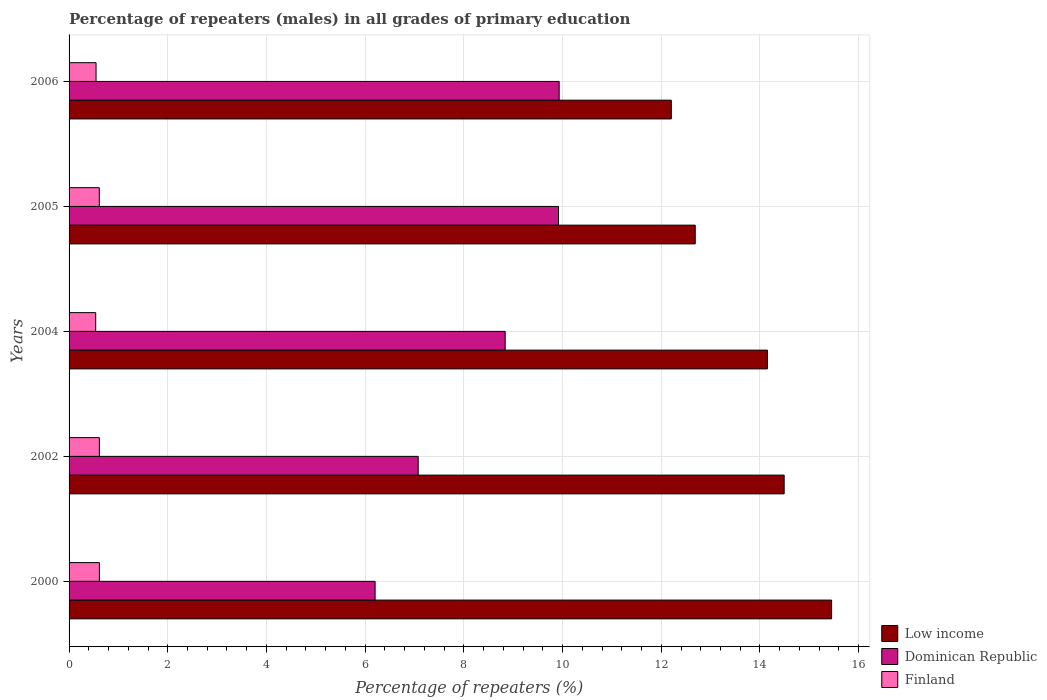How many groups of bars are there?
Offer a terse response. 5. Are the number of bars per tick equal to the number of legend labels?
Your answer should be very brief. Yes. Are the number of bars on each tick of the Y-axis equal?
Make the answer very short. Yes. How many bars are there on the 3rd tick from the bottom?
Offer a very short reply. 3. What is the percentage of repeaters (males) in Dominican Republic in 2006?
Make the answer very short. 9.93. Across all years, what is the maximum percentage of repeaters (males) in Finland?
Make the answer very short. 0.61. Across all years, what is the minimum percentage of repeaters (males) in Dominican Republic?
Offer a very short reply. 6.2. In which year was the percentage of repeaters (males) in Finland maximum?
Ensure brevity in your answer.  2000. What is the total percentage of repeaters (males) in Finland in the graph?
Offer a terse response. 2.93. What is the difference between the percentage of repeaters (males) in Dominican Republic in 2004 and that in 2006?
Offer a terse response. -1.09. What is the difference between the percentage of repeaters (males) in Low income in 2004 and the percentage of repeaters (males) in Dominican Republic in 2002?
Give a very brief answer. 7.08. What is the average percentage of repeaters (males) in Dominican Republic per year?
Give a very brief answer. 8.39. In the year 2000, what is the difference between the percentage of repeaters (males) in Low income and percentage of repeaters (males) in Finland?
Offer a terse response. 14.84. What is the ratio of the percentage of repeaters (males) in Dominican Republic in 2002 to that in 2006?
Offer a terse response. 0.71. Is the percentage of repeaters (males) in Dominican Republic in 2002 less than that in 2006?
Provide a succinct answer. Yes. What is the difference between the highest and the second highest percentage of repeaters (males) in Finland?
Provide a succinct answer. 0. What is the difference between the highest and the lowest percentage of repeaters (males) in Dominican Republic?
Offer a terse response. 3.73. In how many years, is the percentage of repeaters (males) in Low income greater than the average percentage of repeaters (males) in Low income taken over all years?
Your answer should be compact. 3. What does the 2nd bar from the top in 2000 represents?
Provide a short and direct response. Dominican Republic. What does the 1st bar from the bottom in 2005 represents?
Offer a terse response. Low income. Is it the case that in every year, the sum of the percentage of repeaters (males) in Low income and percentage of repeaters (males) in Finland is greater than the percentage of repeaters (males) in Dominican Republic?
Keep it short and to the point. Yes. Are all the bars in the graph horizontal?
Make the answer very short. Yes. What is the difference between two consecutive major ticks on the X-axis?
Provide a short and direct response. 2. Does the graph contain any zero values?
Your answer should be compact. No. What is the title of the graph?
Keep it short and to the point. Percentage of repeaters (males) in all grades of primary education. Does "France" appear as one of the legend labels in the graph?
Give a very brief answer. No. What is the label or title of the X-axis?
Ensure brevity in your answer.  Percentage of repeaters (%). What is the Percentage of repeaters (%) of Low income in 2000?
Provide a short and direct response. 15.45. What is the Percentage of repeaters (%) of Dominican Republic in 2000?
Give a very brief answer. 6.2. What is the Percentage of repeaters (%) of Finland in 2000?
Give a very brief answer. 0.61. What is the Percentage of repeaters (%) in Low income in 2002?
Provide a short and direct response. 14.49. What is the Percentage of repeaters (%) of Dominican Republic in 2002?
Your response must be concise. 7.07. What is the Percentage of repeaters (%) of Finland in 2002?
Give a very brief answer. 0.61. What is the Percentage of repeaters (%) of Low income in 2004?
Make the answer very short. 14.15. What is the Percentage of repeaters (%) in Dominican Republic in 2004?
Offer a terse response. 8.84. What is the Percentage of repeaters (%) of Finland in 2004?
Provide a succinct answer. 0.54. What is the Percentage of repeaters (%) of Low income in 2005?
Give a very brief answer. 12.69. What is the Percentage of repeaters (%) of Dominican Republic in 2005?
Provide a succinct answer. 9.92. What is the Percentage of repeaters (%) of Finland in 2005?
Provide a short and direct response. 0.61. What is the Percentage of repeaters (%) in Low income in 2006?
Your answer should be very brief. 12.2. What is the Percentage of repeaters (%) of Dominican Republic in 2006?
Make the answer very short. 9.93. What is the Percentage of repeaters (%) in Finland in 2006?
Your answer should be very brief. 0.55. Across all years, what is the maximum Percentage of repeaters (%) in Low income?
Your answer should be very brief. 15.45. Across all years, what is the maximum Percentage of repeaters (%) in Dominican Republic?
Give a very brief answer. 9.93. Across all years, what is the maximum Percentage of repeaters (%) of Finland?
Make the answer very short. 0.61. Across all years, what is the minimum Percentage of repeaters (%) in Low income?
Your response must be concise. 12.2. Across all years, what is the minimum Percentage of repeaters (%) in Dominican Republic?
Give a very brief answer. 6.2. Across all years, what is the minimum Percentage of repeaters (%) in Finland?
Offer a terse response. 0.54. What is the total Percentage of repeaters (%) of Low income in the graph?
Ensure brevity in your answer.  68.99. What is the total Percentage of repeaters (%) of Dominican Republic in the graph?
Ensure brevity in your answer.  41.96. What is the total Percentage of repeaters (%) of Finland in the graph?
Make the answer very short. 2.93. What is the difference between the Percentage of repeaters (%) in Low income in 2000 and that in 2002?
Give a very brief answer. 0.96. What is the difference between the Percentage of repeaters (%) in Dominican Republic in 2000 and that in 2002?
Give a very brief answer. -0.87. What is the difference between the Percentage of repeaters (%) in Finland in 2000 and that in 2002?
Give a very brief answer. 0. What is the difference between the Percentage of repeaters (%) of Low income in 2000 and that in 2004?
Provide a short and direct response. 1.3. What is the difference between the Percentage of repeaters (%) in Dominican Republic in 2000 and that in 2004?
Offer a very short reply. -2.64. What is the difference between the Percentage of repeaters (%) in Finland in 2000 and that in 2004?
Your answer should be very brief. 0.07. What is the difference between the Percentage of repeaters (%) in Low income in 2000 and that in 2005?
Your answer should be compact. 2.76. What is the difference between the Percentage of repeaters (%) in Dominican Republic in 2000 and that in 2005?
Offer a very short reply. -3.72. What is the difference between the Percentage of repeaters (%) in Finland in 2000 and that in 2005?
Offer a terse response. 0. What is the difference between the Percentage of repeaters (%) of Low income in 2000 and that in 2006?
Provide a succinct answer. 3.25. What is the difference between the Percentage of repeaters (%) in Dominican Republic in 2000 and that in 2006?
Keep it short and to the point. -3.73. What is the difference between the Percentage of repeaters (%) of Finland in 2000 and that in 2006?
Keep it short and to the point. 0.07. What is the difference between the Percentage of repeaters (%) in Low income in 2002 and that in 2004?
Give a very brief answer. 0.34. What is the difference between the Percentage of repeaters (%) in Dominican Republic in 2002 and that in 2004?
Offer a very short reply. -1.76. What is the difference between the Percentage of repeaters (%) of Finland in 2002 and that in 2004?
Offer a terse response. 0.07. What is the difference between the Percentage of repeaters (%) in Low income in 2002 and that in 2005?
Your answer should be compact. 1.8. What is the difference between the Percentage of repeaters (%) in Dominican Republic in 2002 and that in 2005?
Keep it short and to the point. -2.84. What is the difference between the Percentage of repeaters (%) in Finland in 2002 and that in 2005?
Offer a terse response. 0. What is the difference between the Percentage of repeaters (%) in Low income in 2002 and that in 2006?
Ensure brevity in your answer.  2.29. What is the difference between the Percentage of repeaters (%) in Dominican Republic in 2002 and that in 2006?
Ensure brevity in your answer.  -2.86. What is the difference between the Percentage of repeaters (%) in Finland in 2002 and that in 2006?
Provide a succinct answer. 0.07. What is the difference between the Percentage of repeaters (%) of Low income in 2004 and that in 2005?
Offer a terse response. 1.46. What is the difference between the Percentage of repeaters (%) of Dominican Republic in 2004 and that in 2005?
Your answer should be compact. -1.08. What is the difference between the Percentage of repeaters (%) in Finland in 2004 and that in 2005?
Offer a terse response. -0.07. What is the difference between the Percentage of repeaters (%) in Low income in 2004 and that in 2006?
Ensure brevity in your answer.  1.95. What is the difference between the Percentage of repeaters (%) in Dominican Republic in 2004 and that in 2006?
Offer a terse response. -1.09. What is the difference between the Percentage of repeaters (%) of Finland in 2004 and that in 2006?
Your answer should be very brief. -0.01. What is the difference between the Percentage of repeaters (%) of Low income in 2005 and that in 2006?
Offer a very short reply. 0.48. What is the difference between the Percentage of repeaters (%) in Dominican Republic in 2005 and that in 2006?
Your response must be concise. -0.01. What is the difference between the Percentage of repeaters (%) of Finland in 2005 and that in 2006?
Make the answer very short. 0.07. What is the difference between the Percentage of repeaters (%) in Low income in 2000 and the Percentage of repeaters (%) in Dominican Republic in 2002?
Give a very brief answer. 8.38. What is the difference between the Percentage of repeaters (%) in Low income in 2000 and the Percentage of repeaters (%) in Finland in 2002?
Give a very brief answer. 14.84. What is the difference between the Percentage of repeaters (%) of Dominican Republic in 2000 and the Percentage of repeaters (%) of Finland in 2002?
Ensure brevity in your answer.  5.59. What is the difference between the Percentage of repeaters (%) of Low income in 2000 and the Percentage of repeaters (%) of Dominican Republic in 2004?
Provide a short and direct response. 6.61. What is the difference between the Percentage of repeaters (%) in Low income in 2000 and the Percentage of repeaters (%) in Finland in 2004?
Provide a short and direct response. 14.91. What is the difference between the Percentage of repeaters (%) in Dominican Republic in 2000 and the Percentage of repeaters (%) in Finland in 2004?
Give a very brief answer. 5.66. What is the difference between the Percentage of repeaters (%) of Low income in 2000 and the Percentage of repeaters (%) of Dominican Republic in 2005?
Give a very brief answer. 5.53. What is the difference between the Percentage of repeaters (%) in Low income in 2000 and the Percentage of repeaters (%) in Finland in 2005?
Provide a short and direct response. 14.84. What is the difference between the Percentage of repeaters (%) of Dominican Republic in 2000 and the Percentage of repeaters (%) of Finland in 2005?
Provide a succinct answer. 5.59. What is the difference between the Percentage of repeaters (%) in Low income in 2000 and the Percentage of repeaters (%) in Dominican Republic in 2006?
Offer a terse response. 5.52. What is the difference between the Percentage of repeaters (%) in Low income in 2000 and the Percentage of repeaters (%) in Finland in 2006?
Offer a very short reply. 14.91. What is the difference between the Percentage of repeaters (%) in Dominican Republic in 2000 and the Percentage of repeaters (%) in Finland in 2006?
Offer a terse response. 5.65. What is the difference between the Percentage of repeaters (%) in Low income in 2002 and the Percentage of repeaters (%) in Dominican Republic in 2004?
Give a very brief answer. 5.65. What is the difference between the Percentage of repeaters (%) of Low income in 2002 and the Percentage of repeaters (%) of Finland in 2004?
Ensure brevity in your answer.  13.95. What is the difference between the Percentage of repeaters (%) of Dominican Republic in 2002 and the Percentage of repeaters (%) of Finland in 2004?
Make the answer very short. 6.53. What is the difference between the Percentage of repeaters (%) in Low income in 2002 and the Percentage of repeaters (%) in Dominican Republic in 2005?
Keep it short and to the point. 4.57. What is the difference between the Percentage of repeaters (%) of Low income in 2002 and the Percentage of repeaters (%) of Finland in 2005?
Your response must be concise. 13.88. What is the difference between the Percentage of repeaters (%) in Dominican Republic in 2002 and the Percentage of repeaters (%) in Finland in 2005?
Make the answer very short. 6.46. What is the difference between the Percentage of repeaters (%) of Low income in 2002 and the Percentage of repeaters (%) of Dominican Republic in 2006?
Provide a short and direct response. 4.56. What is the difference between the Percentage of repeaters (%) of Low income in 2002 and the Percentage of repeaters (%) of Finland in 2006?
Your response must be concise. 13.94. What is the difference between the Percentage of repeaters (%) in Dominican Republic in 2002 and the Percentage of repeaters (%) in Finland in 2006?
Your answer should be very brief. 6.53. What is the difference between the Percentage of repeaters (%) of Low income in 2004 and the Percentage of repeaters (%) of Dominican Republic in 2005?
Your response must be concise. 4.23. What is the difference between the Percentage of repeaters (%) of Low income in 2004 and the Percentage of repeaters (%) of Finland in 2005?
Offer a very short reply. 13.54. What is the difference between the Percentage of repeaters (%) of Dominican Republic in 2004 and the Percentage of repeaters (%) of Finland in 2005?
Provide a short and direct response. 8.22. What is the difference between the Percentage of repeaters (%) of Low income in 2004 and the Percentage of repeaters (%) of Dominican Republic in 2006?
Ensure brevity in your answer.  4.22. What is the difference between the Percentage of repeaters (%) of Low income in 2004 and the Percentage of repeaters (%) of Finland in 2006?
Keep it short and to the point. 13.6. What is the difference between the Percentage of repeaters (%) of Dominican Republic in 2004 and the Percentage of repeaters (%) of Finland in 2006?
Offer a terse response. 8.29. What is the difference between the Percentage of repeaters (%) in Low income in 2005 and the Percentage of repeaters (%) in Dominican Republic in 2006?
Your answer should be very brief. 2.76. What is the difference between the Percentage of repeaters (%) of Low income in 2005 and the Percentage of repeaters (%) of Finland in 2006?
Provide a succinct answer. 12.14. What is the difference between the Percentage of repeaters (%) in Dominican Republic in 2005 and the Percentage of repeaters (%) in Finland in 2006?
Offer a very short reply. 9.37. What is the average Percentage of repeaters (%) in Low income per year?
Give a very brief answer. 13.8. What is the average Percentage of repeaters (%) in Dominican Republic per year?
Give a very brief answer. 8.39. What is the average Percentage of repeaters (%) of Finland per year?
Provide a short and direct response. 0.59. In the year 2000, what is the difference between the Percentage of repeaters (%) of Low income and Percentage of repeaters (%) of Dominican Republic?
Your answer should be very brief. 9.25. In the year 2000, what is the difference between the Percentage of repeaters (%) of Low income and Percentage of repeaters (%) of Finland?
Provide a succinct answer. 14.84. In the year 2000, what is the difference between the Percentage of repeaters (%) in Dominican Republic and Percentage of repeaters (%) in Finland?
Ensure brevity in your answer.  5.59. In the year 2002, what is the difference between the Percentage of repeaters (%) in Low income and Percentage of repeaters (%) in Dominican Republic?
Provide a succinct answer. 7.42. In the year 2002, what is the difference between the Percentage of repeaters (%) of Low income and Percentage of repeaters (%) of Finland?
Give a very brief answer. 13.88. In the year 2002, what is the difference between the Percentage of repeaters (%) in Dominican Republic and Percentage of repeaters (%) in Finland?
Keep it short and to the point. 6.46. In the year 2004, what is the difference between the Percentage of repeaters (%) in Low income and Percentage of repeaters (%) in Dominican Republic?
Provide a short and direct response. 5.31. In the year 2004, what is the difference between the Percentage of repeaters (%) in Low income and Percentage of repeaters (%) in Finland?
Keep it short and to the point. 13.61. In the year 2004, what is the difference between the Percentage of repeaters (%) of Dominican Republic and Percentage of repeaters (%) of Finland?
Ensure brevity in your answer.  8.3. In the year 2005, what is the difference between the Percentage of repeaters (%) of Low income and Percentage of repeaters (%) of Dominican Republic?
Ensure brevity in your answer.  2.77. In the year 2005, what is the difference between the Percentage of repeaters (%) in Low income and Percentage of repeaters (%) in Finland?
Keep it short and to the point. 12.08. In the year 2005, what is the difference between the Percentage of repeaters (%) of Dominican Republic and Percentage of repeaters (%) of Finland?
Provide a short and direct response. 9.31. In the year 2006, what is the difference between the Percentage of repeaters (%) in Low income and Percentage of repeaters (%) in Dominican Republic?
Keep it short and to the point. 2.27. In the year 2006, what is the difference between the Percentage of repeaters (%) in Low income and Percentage of repeaters (%) in Finland?
Ensure brevity in your answer.  11.66. In the year 2006, what is the difference between the Percentage of repeaters (%) of Dominican Republic and Percentage of repeaters (%) of Finland?
Your answer should be very brief. 9.38. What is the ratio of the Percentage of repeaters (%) in Low income in 2000 to that in 2002?
Your answer should be compact. 1.07. What is the ratio of the Percentage of repeaters (%) of Dominican Republic in 2000 to that in 2002?
Provide a succinct answer. 0.88. What is the ratio of the Percentage of repeaters (%) in Finland in 2000 to that in 2002?
Ensure brevity in your answer.  1. What is the ratio of the Percentage of repeaters (%) of Low income in 2000 to that in 2004?
Make the answer very short. 1.09. What is the ratio of the Percentage of repeaters (%) of Dominican Republic in 2000 to that in 2004?
Give a very brief answer. 0.7. What is the ratio of the Percentage of repeaters (%) in Finland in 2000 to that in 2004?
Offer a very short reply. 1.14. What is the ratio of the Percentage of repeaters (%) of Low income in 2000 to that in 2005?
Provide a short and direct response. 1.22. What is the ratio of the Percentage of repeaters (%) in Dominican Republic in 2000 to that in 2005?
Offer a terse response. 0.63. What is the ratio of the Percentage of repeaters (%) of Finland in 2000 to that in 2005?
Your answer should be compact. 1. What is the ratio of the Percentage of repeaters (%) in Low income in 2000 to that in 2006?
Give a very brief answer. 1.27. What is the ratio of the Percentage of repeaters (%) of Dominican Republic in 2000 to that in 2006?
Your answer should be compact. 0.62. What is the ratio of the Percentage of repeaters (%) in Finland in 2000 to that in 2006?
Offer a very short reply. 1.12. What is the ratio of the Percentage of repeaters (%) of Dominican Republic in 2002 to that in 2004?
Offer a terse response. 0.8. What is the ratio of the Percentage of repeaters (%) of Finland in 2002 to that in 2004?
Offer a very short reply. 1.14. What is the ratio of the Percentage of repeaters (%) in Low income in 2002 to that in 2005?
Ensure brevity in your answer.  1.14. What is the ratio of the Percentage of repeaters (%) in Dominican Republic in 2002 to that in 2005?
Your answer should be very brief. 0.71. What is the ratio of the Percentage of repeaters (%) in Finland in 2002 to that in 2005?
Offer a terse response. 1. What is the ratio of the Percentage of repeaters (%) of Low income in 2002 to that in 2006?
Your answer should be very brief. 1.19. What is the ratio of the Percentage of repeaters (%) of Dominican Republic in 2002 to that in 2006?
Your response must be concise. 0.71. What is the ratio of the Percentage of repeaters (%) of Finland in 2002 to that in 2006?
Offer a terse response. 1.12. What is the ratio of the Percentage of repeaters (%) in Low income in 2004 to that in 2005?
Make the answer very short. 1.12. What is the ratio of the Percentage of repeaters (%) in Dominican Republic in 2004 to that in 2005?
Offer a very short reply. 0.89. What is the ratio of the Percentage of repeaters (%) in Finland in 2004 to that in 2005?
Ensure brevity in your answer.  0.88. What is the ratio of the Percentage of repeaters (%) of Low income in 2004 to that in 2006?
Make the answer very short. 1.16. What is the ratio of the Percentage of repeaters (%) of Dominican Republic in 2004 to that in 2006?
Offer a terse response. 0.89. What is the ratio of the Percentage of repeaters (%) of Low income in 2005 to that in 2006?
Keep it short and to the point. 1.04. What is the ratio of the Percentage of repeaters (%) of Finland in 2005 to that in 2006?
Provide a short and direct response. 1.12. What is the difference between the highest and the second highest Percentage of repeaters (%) in Low income?
Your response must be concise. 0.96. What is the difference between the highest and the second highest Percentage of repeaters (%) in Dominican Republic?
Your response must be concise. 0.01. What is the difference between the highest and the second highest Percentage of repeaters (%) in Finland?
Keep it short and to the point. 0. What is the difference between the highest and the lowest Percentage of repeaters (%) of Low income?
Offer a very short reply. 3.25. What is the difference between the highest and the lowest Percentage of repeaters (%) of Dominican Republic?
Provide a short and direct response. 3.73. What is the difference between the highest and the lowest Percentage of repeaters (%) in Finland?
Your answer should be compact. 0.07. 